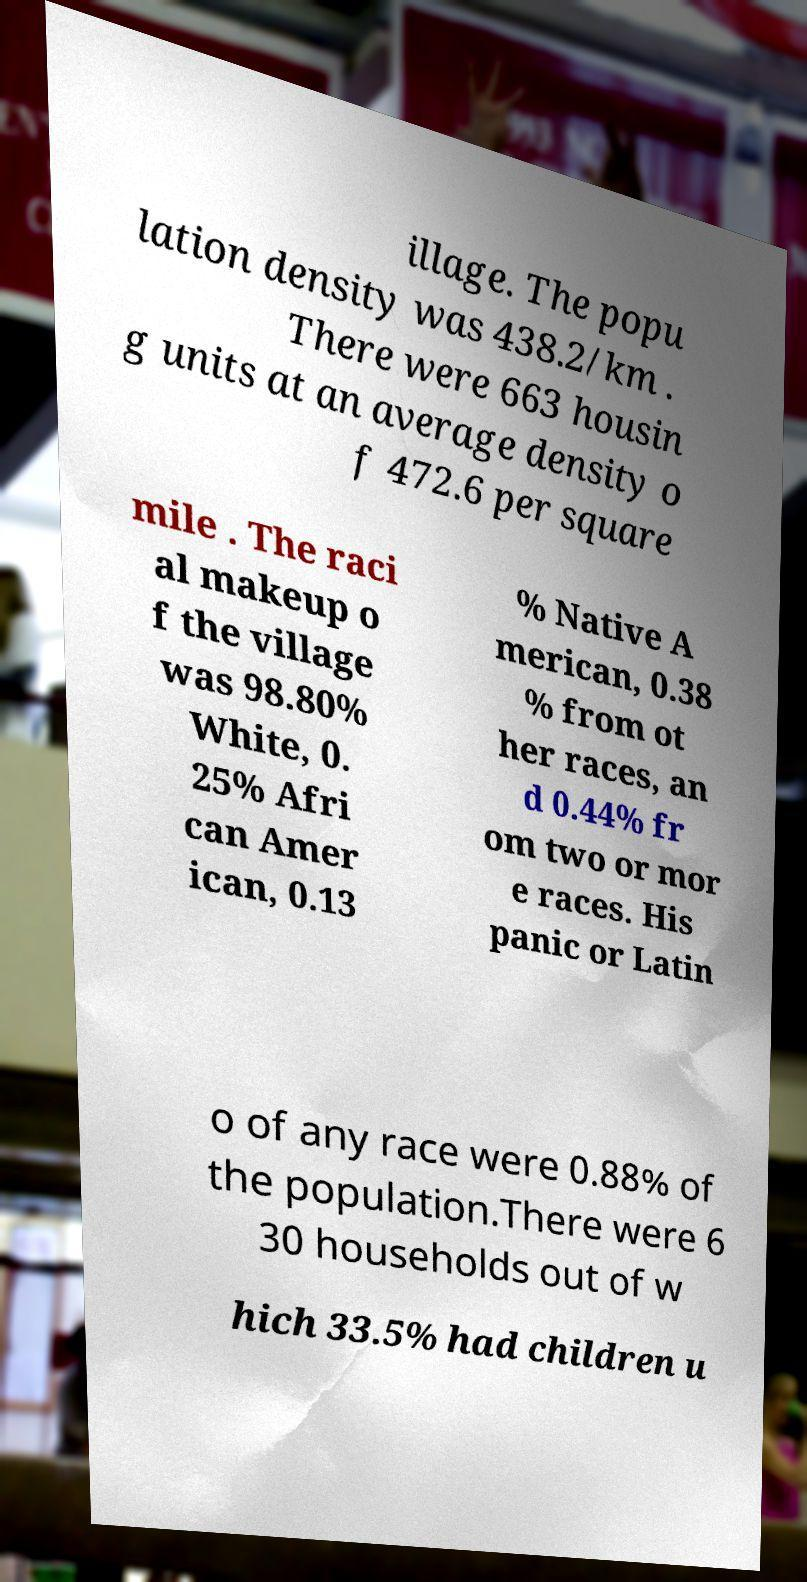Please read and relay the text visible in this image. What does it say? illage. The popu lation density was 438.2/km . There were 663 housin g units at an average density o f 472.6 per square mile . The raci al makeup o f the village was 98.80% White, 0. 25% Afri can Amer ican, 0.13 % Native A merican, 0.38 % from ot her races, an d 0.44% fr om two or mor e races. His panic or Latin o of any race were 0.88% of the population.There were 6 30 households out of w hich 33.5% had children u 